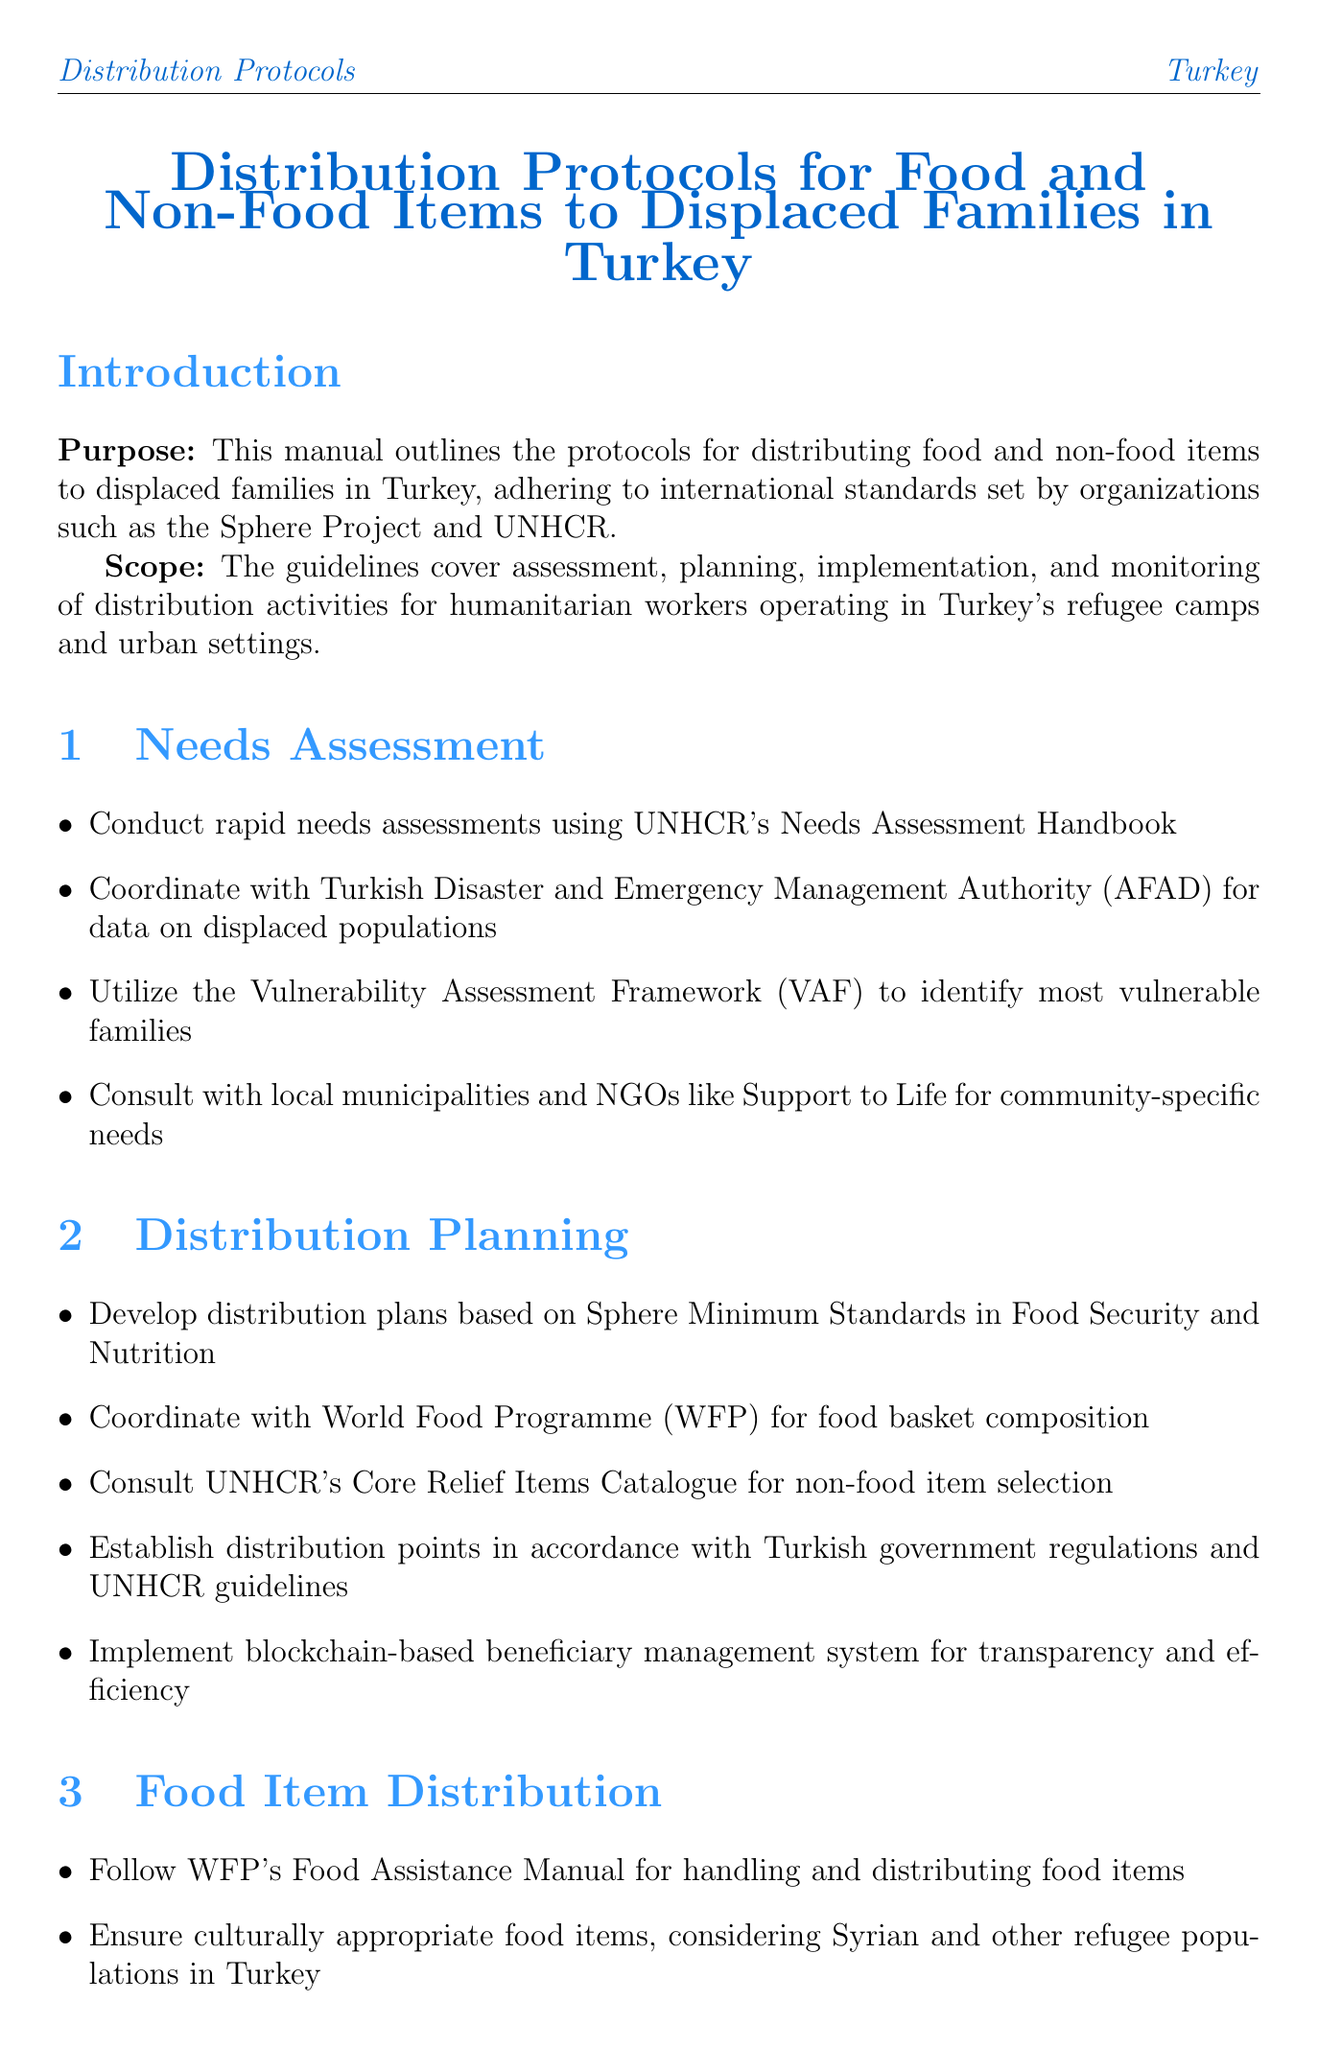What is the manual title? The manual title is provided in the introduction section and gives the main focus of the document.
Answer: Distribution Protocols for Food and Non-Food Items to Displaced Families in Turkey What framework is used to identify vulnerable families? A specific framework mentioned in the Needs Assessment section is utilized for identifying families in need.
Answer: Vulnerability Assessment Framework (VAF) Which organization provides the Core Relief Items Catalogue? This organization is listed in the Distribution Planning section and is known for providing support in refugee situations.
Answer: UNHCR What item distribution system is implemented for urban refugees? This refers to the specific technology-based system mentioned in the Food Item Distribution section.
Answer: E-Food Card system What type of items should be provided in winterization? This refers to specific items that are crucial during the winter months, mentioned in the Non-Food Item Distribution section.
Answer: Blankets, heaters Which guideline is followed for gender-based violence interventions? This guideline is highlighted in the Protection and Accountability section as a standard for interventions.
Answer: IASC Guidelines How often should food quality checks be conducted? This aspect of monitoring food safety is addressed in the Food Item Distribution section, outlining the frequency of checks.
Answer: Regular What does PDM stand for? This acronym is introduced in the Protection and Accountability section and relates to a monitoring activity.
Answer: Post-Distribution Monitoring What is the purpose of the annexes in this manual? The annexes provide additional information that supports the main document, as stated in the structure of the manual.
Answer: Additional information 